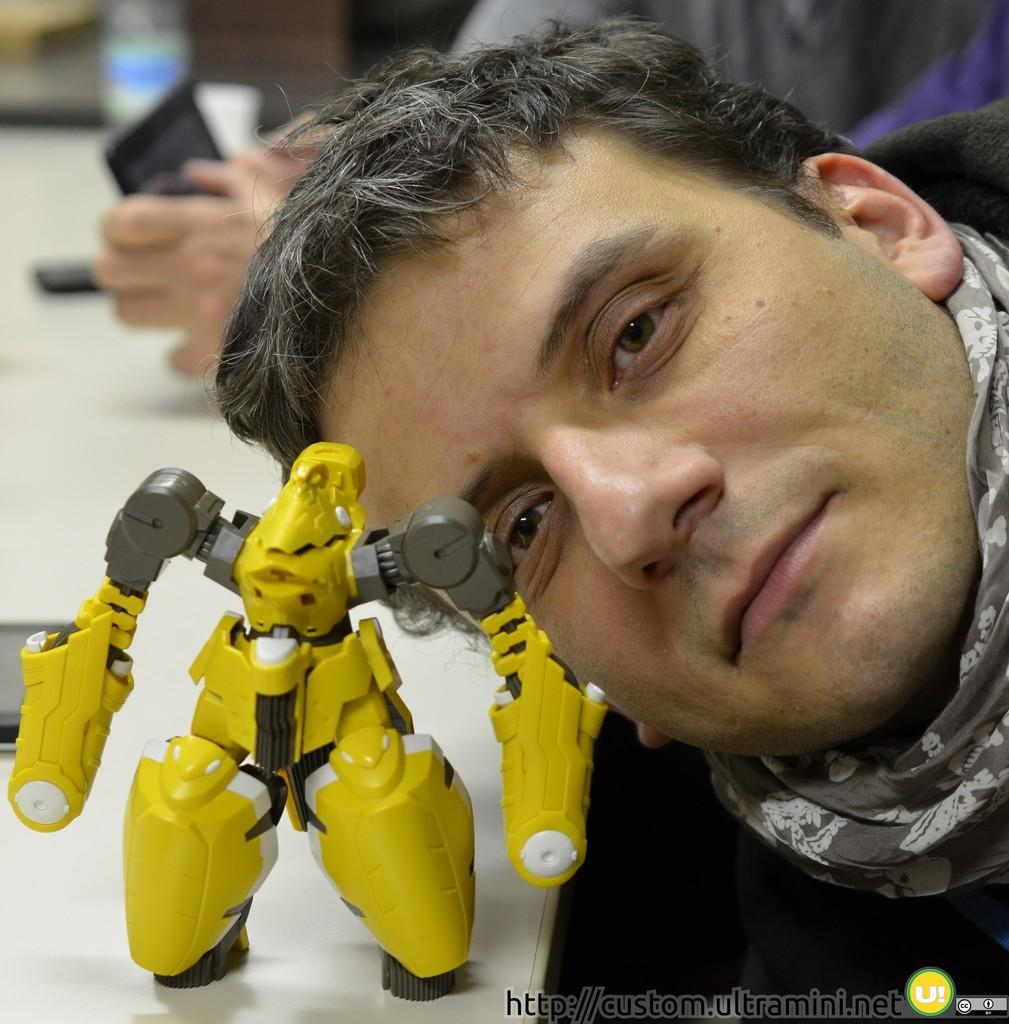Who or what is present in the image? There is a person in the image. What object is on the table in the image? There is a robot on a table. What electronic device can be seen in the background of the image? There is a smartphone in the background. What is another object on the table in the image? There is a water bottle on the table. What time of day is it in the image, and who is talking to the robot? The time of day is not mentioned in the image, and there is no indication of anyone talking to the robot. 